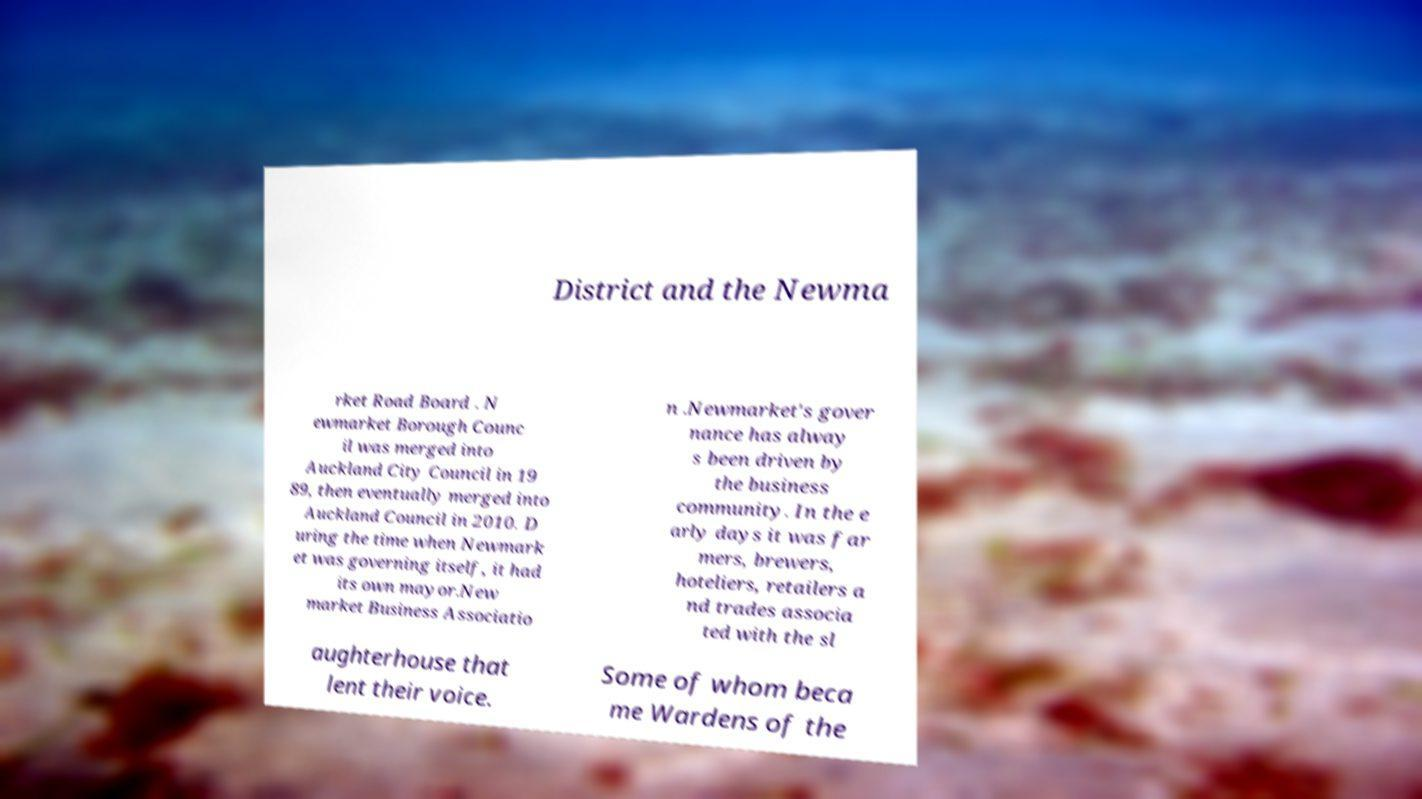Can you accurately transcribe the text from the provided image for me? District and the Newma rket Road Board . N ewmarket Borough Counc il was merged into Auckland City Council in 19 89, then eventually merged into Auckland Council in 2010. D uring the time when Newmark et was governing itself, it had its own mayor.New market Business Associatio n .Newmarket's gover nance has alway s been driven by the business community. In the e arly days it was far mers, brewers, hoteliers, retailers a nd trades associa ted with the sl aughterhouse that lent their voice. Some of whom beca me Wardens of the 